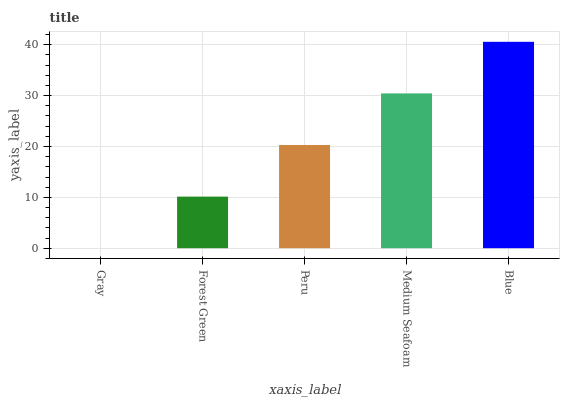Is Forest Green the minimum?
Answer yes or no. No. Is Forest Green the maximum?
Answer yes or no. No. Is Forest Green greater than Gray?
Answer yes or no. Yes. Is Gray less than Forest Green?
Answer yes or no. Yes. Is Gray greater than Forest Green?
Answer yes or no. No. Is Forest Green less than Gray?
Answer yes or no. No. Is Peru the high median?
Answer yes or no. Yes. Is Peru the low median?
Answer yes or no. Yes. Is Medium Seafoam the high median?
Answer yes or no. No. Is Gray the low median?
Answer yes or no. No. 